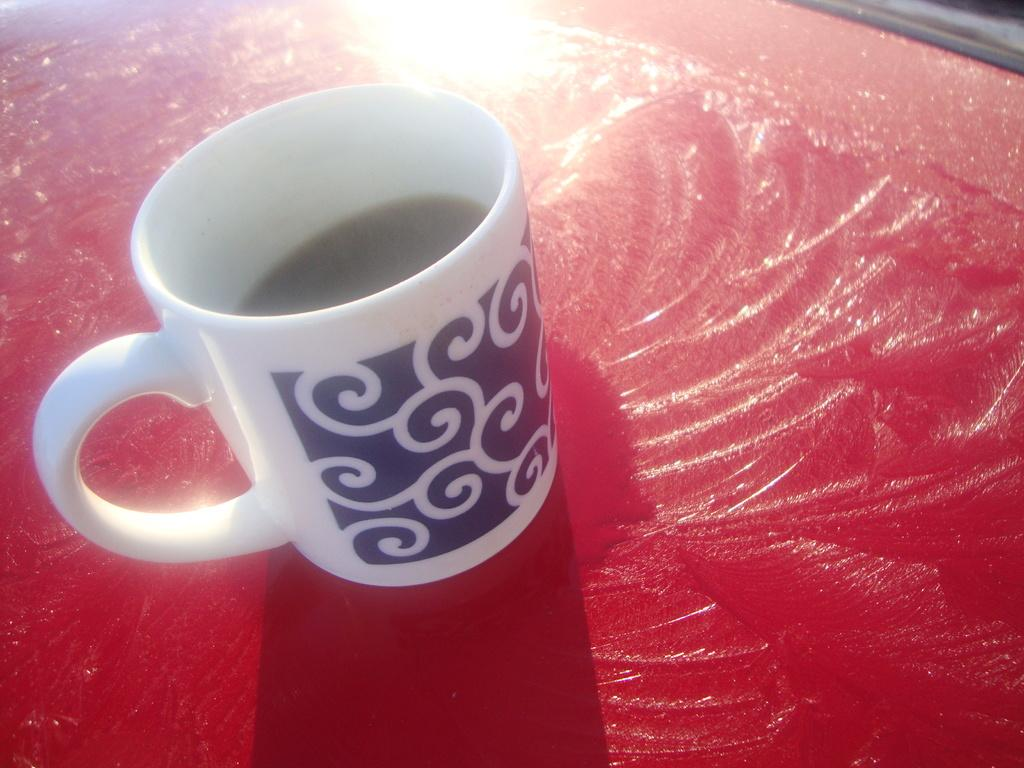What object is present in the image? There is a cup in the image. What color is the cup? The cup is black and white in color. What is inside the cup? There is liquid in the cup. What is the color of the surface the cup is placed on? The cup is on a red-colored surface. What type of credit can be seen being offered to the dog in the image? There is no dog or credit present in the image. 